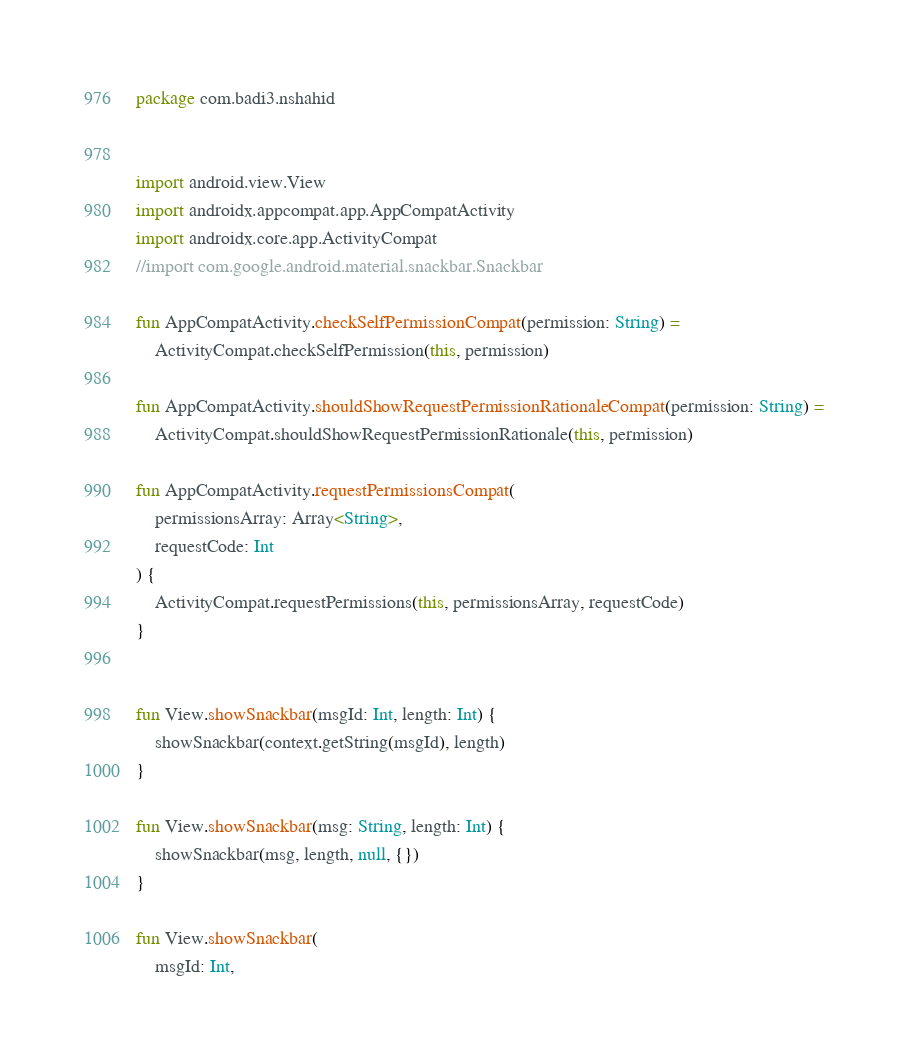<code> <loc_0><loc_0><loc_500><loc_500><_Kotlin_>package com.badi3.nshahid


import android.view.View
import androidx.appcompat.app.AppCompatActivity
import androidx.core.app.ActivityCompat
//import com.google.android.material.snackbar.Snackbar

fun AppCompatActivity.checkSelfPermissionCompat(permission: String) =
    ActivityCompat.checkSelfPermission(this, permission)

fun AppCompatActivity.shouldShowRequestPermissionRationaleCompat(permission: String) =
    ActivityCompat.shouldShowRequestPermissionRationale(this, permission)

fun AppCompatActivity.requestPermissionsCompat(
    permissionsArray: Array<String>,
    requestCode: Int
) {
    ActivityCompat.requestPermissions(this, permissionsArray, requestCode)
}


fun View.showSnackbar(msgId: Int, length: Int) {
    showSnackbar(context.getString(msgId), length)
}

fun View.showSnackbar(msg: String, length: Int) {
    showSnackbar(msg, length, null, {})
}

fun View.showSnackbar(
    msgId: Int,</code> 